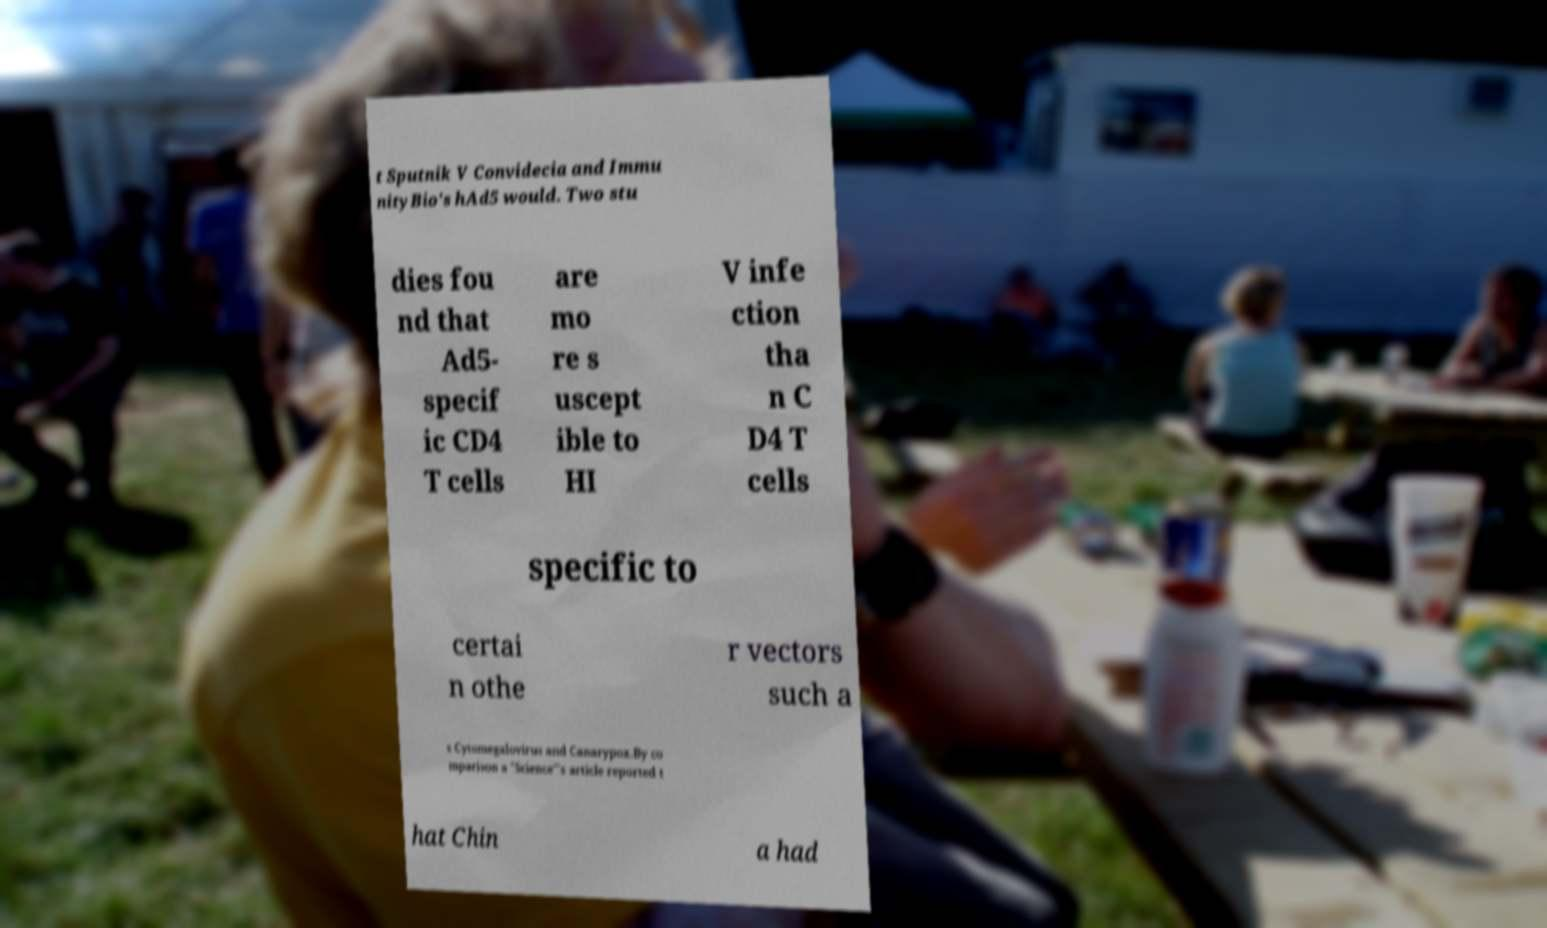Could you assist in decoding the text presented in this image and type it out clearly? t Sputnik V Convidecia and Immu nityBio's hAd5 would. Two stu dies fou nd that Ad5- specif ic CD4 T cells are mo re s uscept ible to HI V infe ction tha n C D4 T cells specific to certai n othe r vectors such a s Cytomegalovirus and Canarypox.By co mparison a "Science"'s article reported t hat Chin a had 